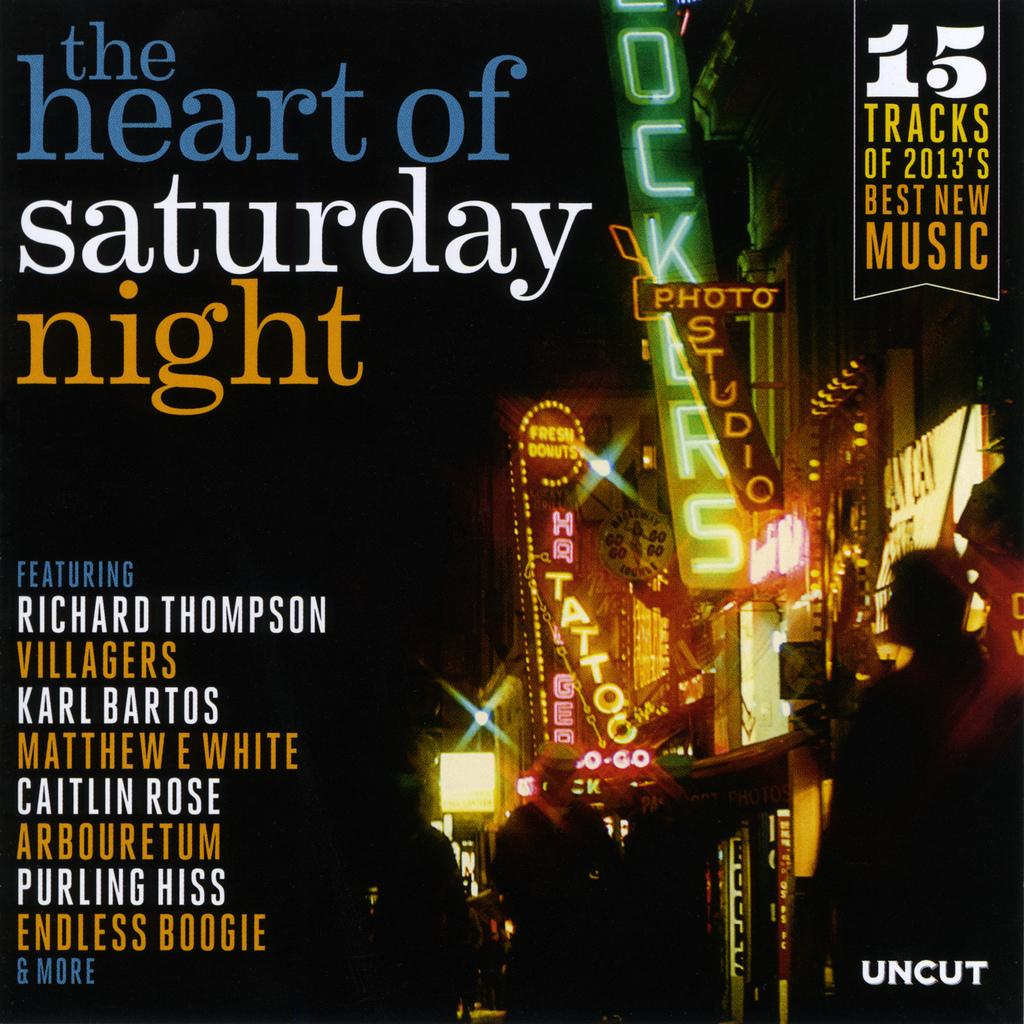<image>
Provide a brief description of the given image. An uncut album cover featuring the heart of Saturday night. 